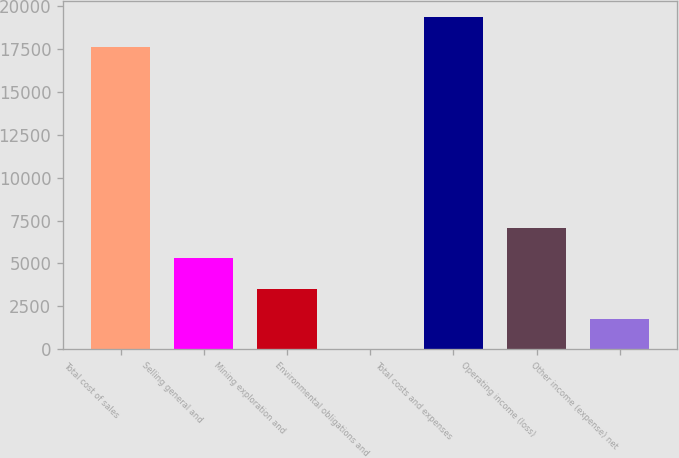<chart> <loc_0><loc_0><loc_500><loc_500><bar_chart><fcel>Total cost of sales<fcel>Selling general and<fcel>Mining exploration and<fcel>Environmental obligations and<fcel>Total costs and expenses<fcel>Operating income (loss)<fcel>Other income (expense) net<nl><fcel>17580<fcel>5300.6<fcel>3540.4<fcel>20<fcel>19340.2<fcel>7060.8<fcel>1780.2<nl></chart> 